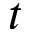Convert formula to latex. <formula><loc_0><loc_0><loc_500><loc_500>t</formula> 